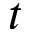Convert formula to latex. <formula><loc_0><loc_0><loc_500><loc_500>t</formula> 